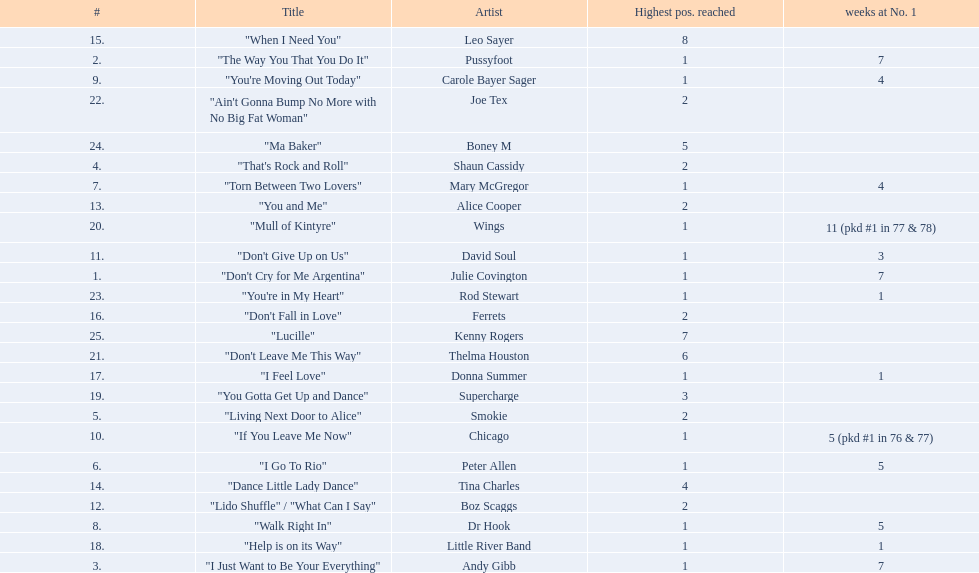Which artists were included in the top 25 singles for 1977 in australia? Julie Covington, Pussyfoot, Andy Gibb, Shaun Cassidy, Smokie, Peter Allen, Mary McGregor, Dr Hook, Carole Bayer Sager, Chicago, David Soul, Boz Scaggs, Alice Cooper, Tina Charles, Leo Sayer, Ferrets, Donna Summer, Little River Band, Supercharge, Wings, Thelma Houston, Joe Tex, Rod Stewart, Boney M, Kenny Rogers. Parse the table in full. {'header': ['#', 'Title', 'Artist', 'Highest pos. reached', 'weeks at No. 1'], 'rows': [['15.', '"When I Need You"', 'Leo Sayer', '8', ''], ['2.', '"The Way You That You Do It"', 'Pussyfoot', '1', '7'], ['9.', '"You\'re Moving Out Today"', 'Carole Bayer Sager', '1', '4'], ['22.', '"Ain\'t Gonna Bump No More with No Big Fat Woman"', 'Joe Tex', '2', ''], ['24.', '"Ma Baker"', 'Boney M', '5', ''], ['4.', '"That\'s Rock and Roll"', 'Shaun Cassidy', '2', ''], ['7.', '"Torn Between Two Lovers"', 'Mary McGregor', '1', '4'], ['13.', '"You and Me"', 'Alice Cooper', '2', ''], ['20.', '"Mull of Kintyre"', 'Wings', '1', '11 (pkd #1 in 77 & 78)'], ['11.', '"Don\'t Give Up on Us"', 'David Soul', '1', '3'], ['1.', '"Don\'t Cry for Me Argentina"', 'Julie Covington', '1', '7'], ['23.', '"You\'re in My Heart"', 'Rod Stewart', '1', '1'], ['16.', '"Don\'t Fall in Love"', 'Ferrets', '2', ''], ['25.', '"Lucille"', 'Kenny Rogers', '7', ''], ['21.', '"Don\'t Leave Me This Way"', 'Thelma Houston', '6', ''], ['17.', '"I Feel Love"', 'Donna Summer', '1', '1'], ['19.', '"You Gotta Get Up and Dance"', 'Supercharge', '3', ''], ['5.', '"Living Next Door to Alice"', 'Smokie', '2', ''], ['10.', '"If You Leave Me Now"', 'Chicago', '1', '5 (pkd #1 in 76 & 77)'], ['6.', '"I Go To Rio"', 'Peter Allen', '1', '5'], ['14.', '"Dance Little Lady Dance"', 'Tina Charles', '4', ''], ['12.', '"Lido Shuffle" / "What Can I Say"', 'Boz Scaggs', '2', ''], ['8.', '"Walk Right In"', 'Dr Hook', '1', '5'], ['18.', '"Help is on its Way"', 'Little River Band', '1', '1'], ['3.', '"I Just Want to Be Your Everything"', 'Andy Gibb', '1', '7']]} And for how many weeks did they chart at number 1? 7, 7, 7, , , 5, 4, 5, 4, 5 (pkd #1 in 76 & 77), 3, , , , , , 1, 1, , 11 (pkd #1 in 77 & 78), , , 1, , . Which artist was in the number 1 spot for most time? Wings. 